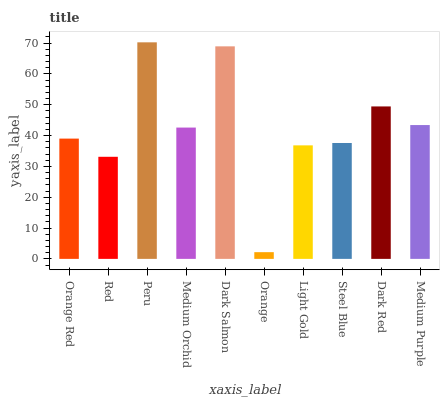Is Orange the minimum?
Answer yes or no. Yes. Is Peru the maximum?
Answer yes or no. Yes. Is Red the minimum?
Answer yes or no. No. Is Red the maximum?
Answer yes or no. No. Is Orange Red greater than Red?
Answer yes or no. Yes. Is Red less than Orange Red?
Answer yes or no. Yes. Is Red greater than Orange Red?
Answer yes or no. No. Is Orange Red less than Red?
Answer yes or no. No. Is Medium Orchid the high median?
Answer yes or no. Yes. Is Orange Red the low median?
Answer yes or no. Yes. Is Steel Blue the high median?
Answer yes or no. No. Is Medium Purple the low median?
Answer yes or no. No. 